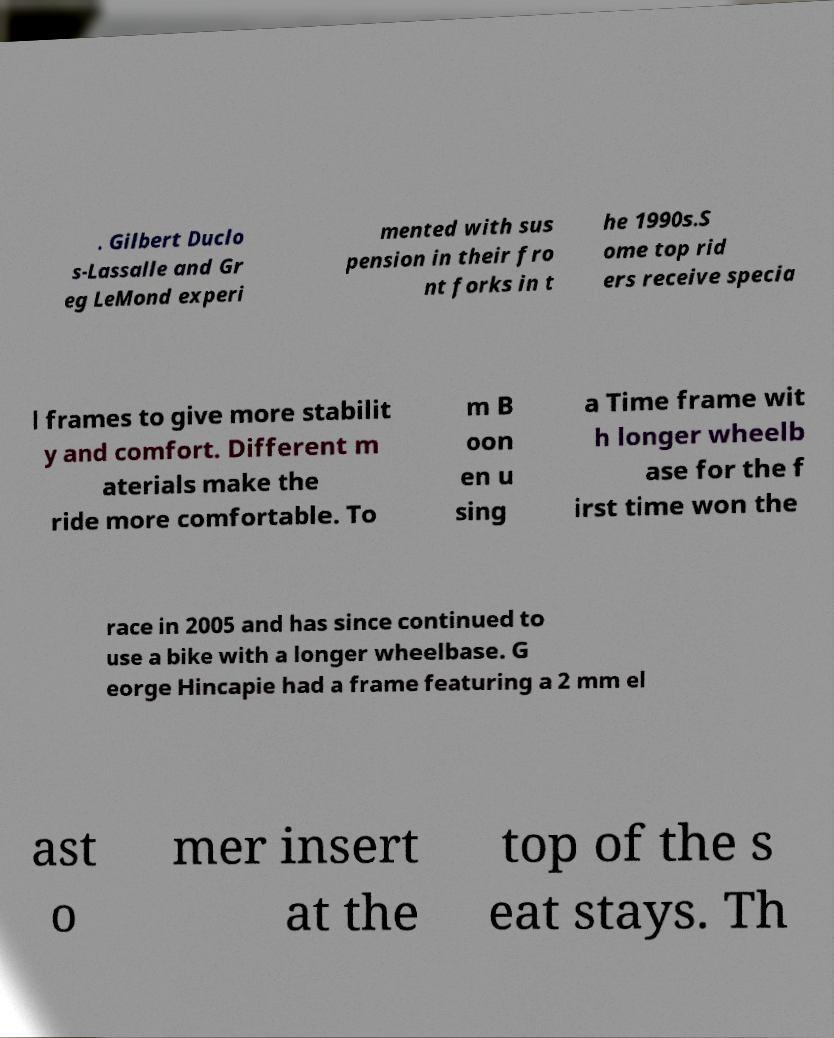I need the written content from this picture converted into text. Can you do that? . Gilbert Duclo s-Lassalle and Gr eg LeMond experi mented with sus pension in their fro nt forks in t he 1990s.S ome top rid ers receive specia l frames to give more stabilit y and comfort. Different m aterials make the ride more comfortable. To m B oon en u sing a Time frame wit h longer wheelb ase for the f irst time won the race in 2005 and has since continued to use a bike with a longer wheelbase. G eorge Hincapie had a frame featuring a 2 mm el ast o mer insert at the top of the s eat stays. Th 